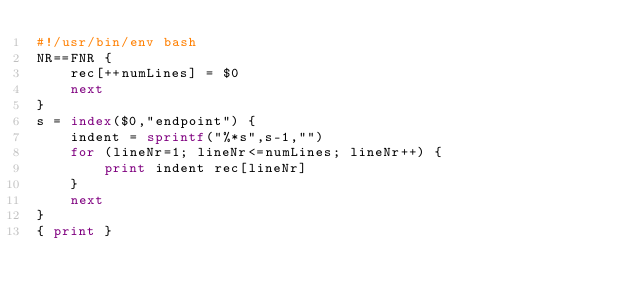Convert code to text. <code><loc_0><loc_0><loc_500><loc_500><_Awk_>#!/usr/bin/env bash
NR==FNR {
    rec[++numLines] = $0
    next
}
s = index($0,"endpoint") {
    indent = sprintf("%*s",s-1,"")
    for (lineNr=1; lineNr<=numLines; lineNr++) {
        print indent rec[lineNr]
    }
    next
}
{ print }</code> 